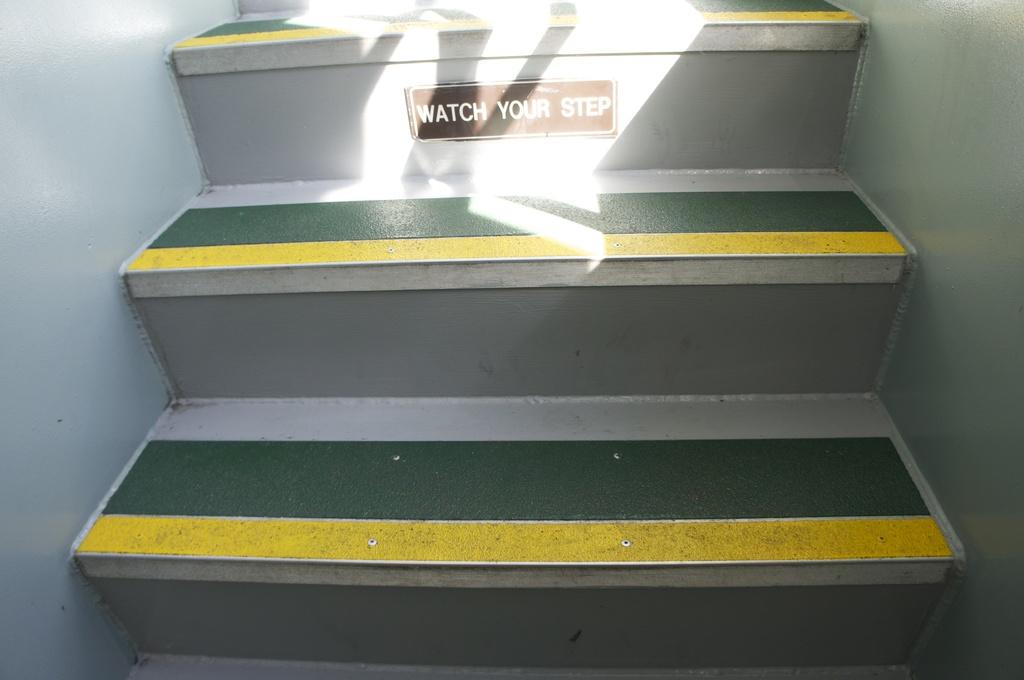What type of structure is present in the image? There are stairs in the image. What is written or depicted on the stairs? There is text on the stairs. What can be seen on either side of the stairs? There are walls on both the right and left sides of the stairs. Where are the flowers and crate located in the image? There are no flowers or crates present in the image. What type of breakfast is being served on the stairs? There is no breakfast depicted in the image. 